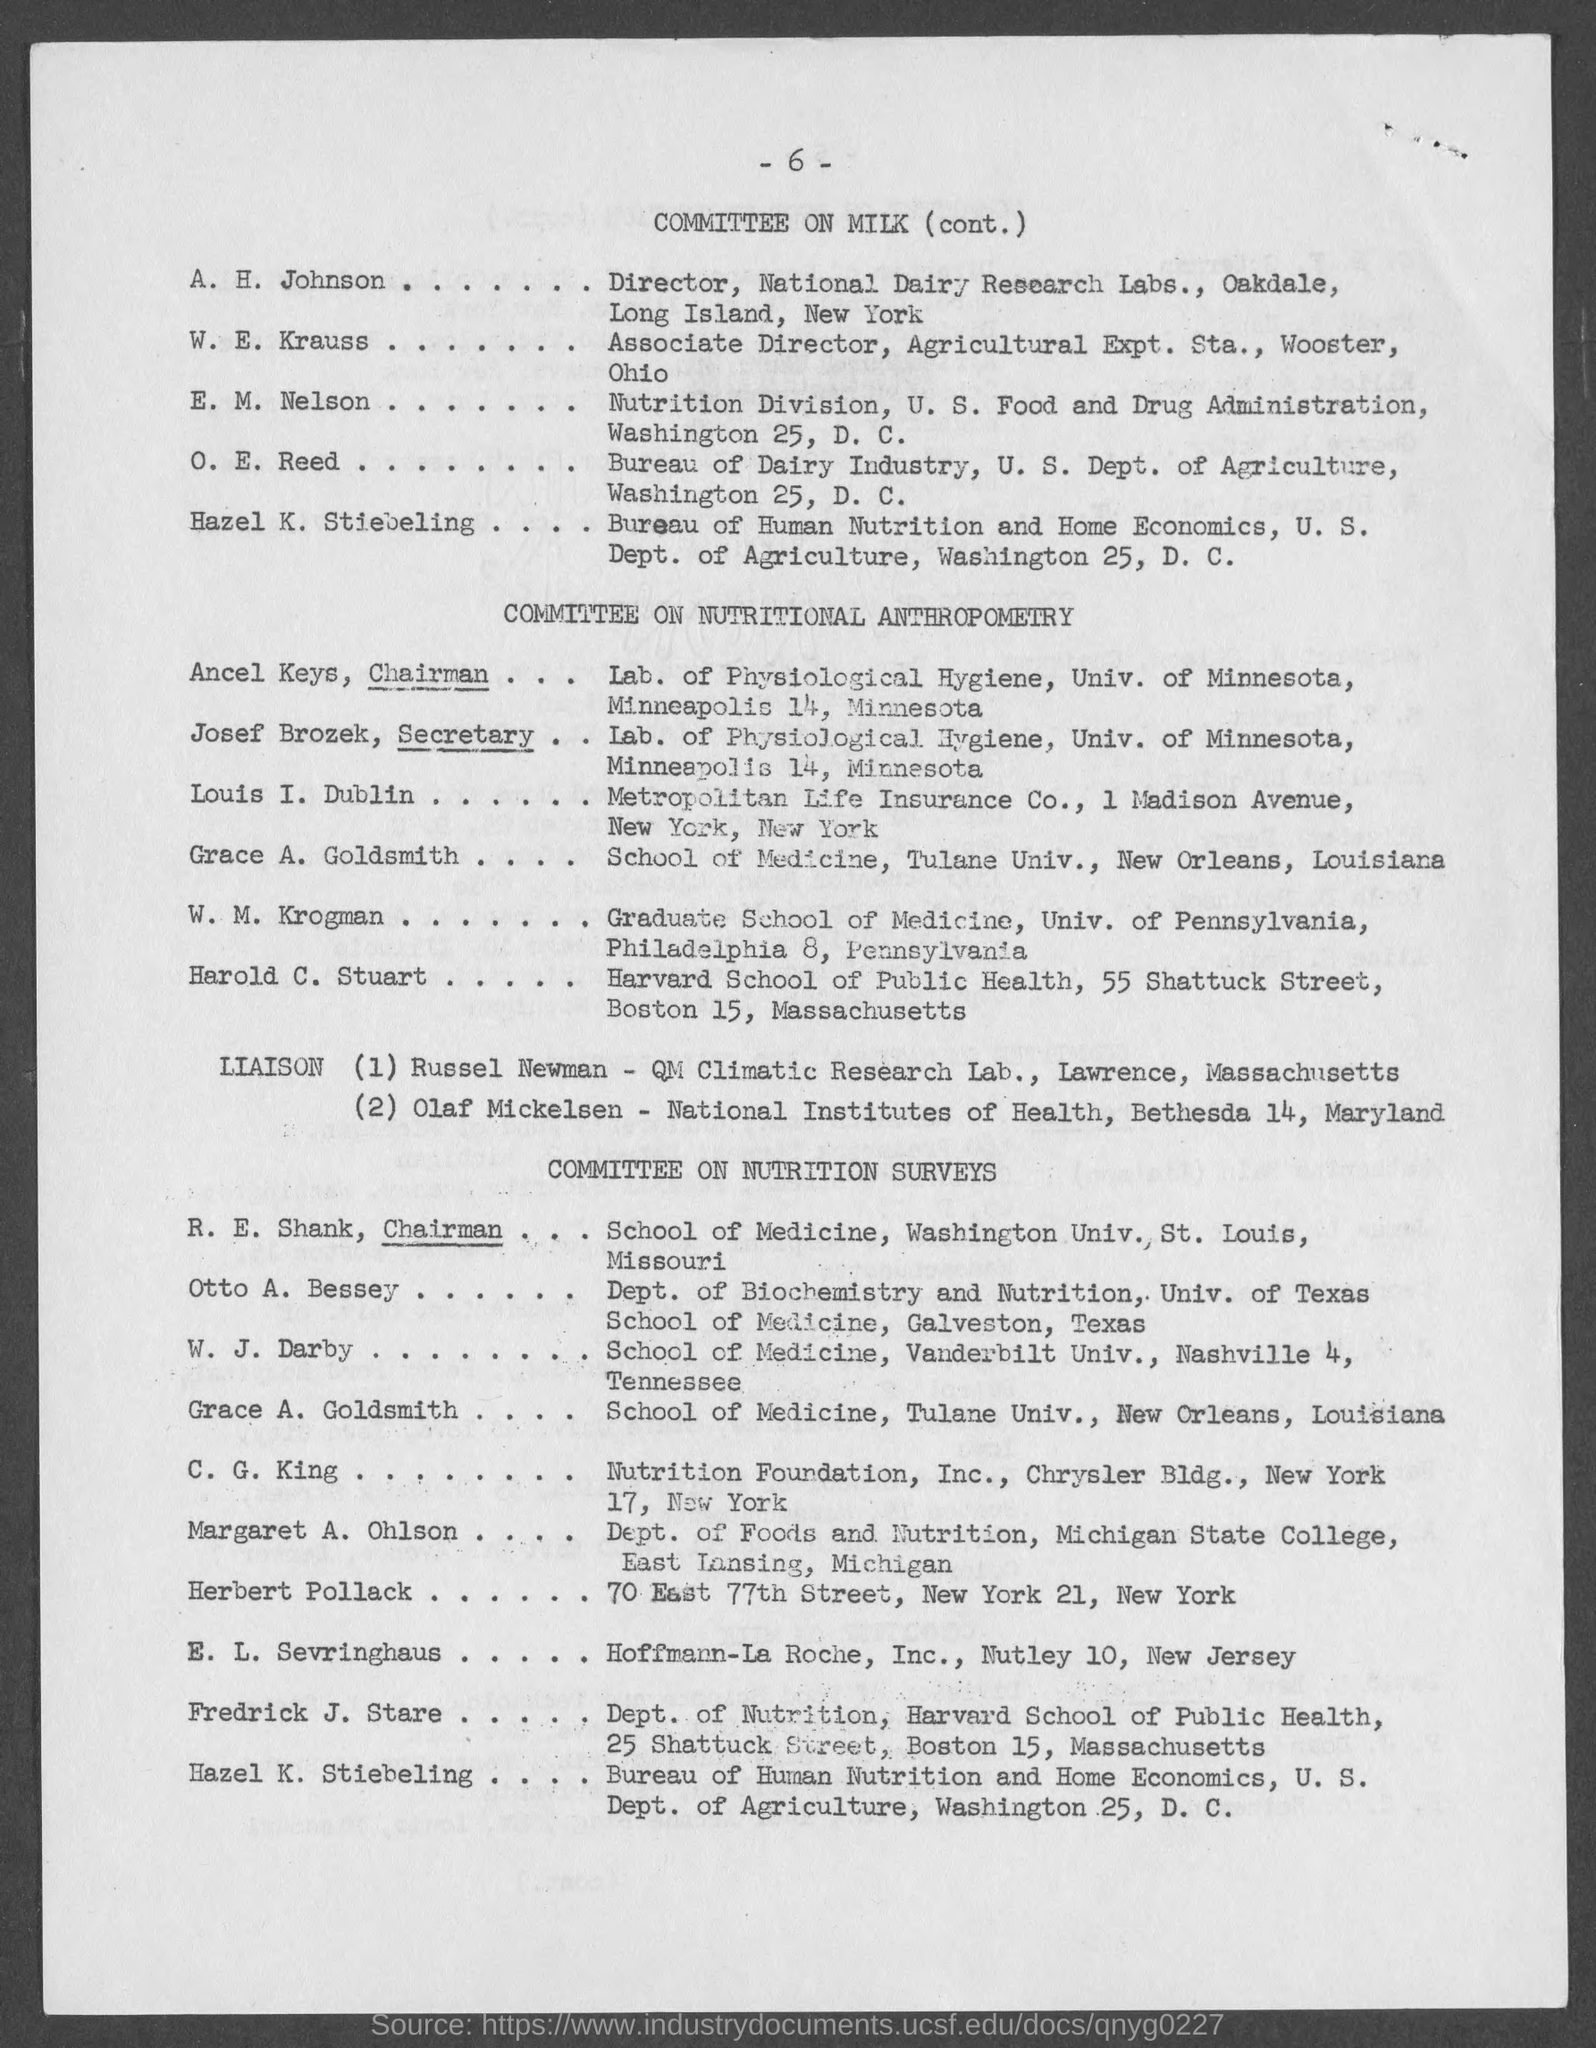Outline some significant characteristics in this image. The Secretary of the Committee on Nutritional Anthropometry is Josef Brozek. Ancel Keys is the Chairman of the Committee on Nutritional Anthropometry. The page number provided in this document is 6.. 